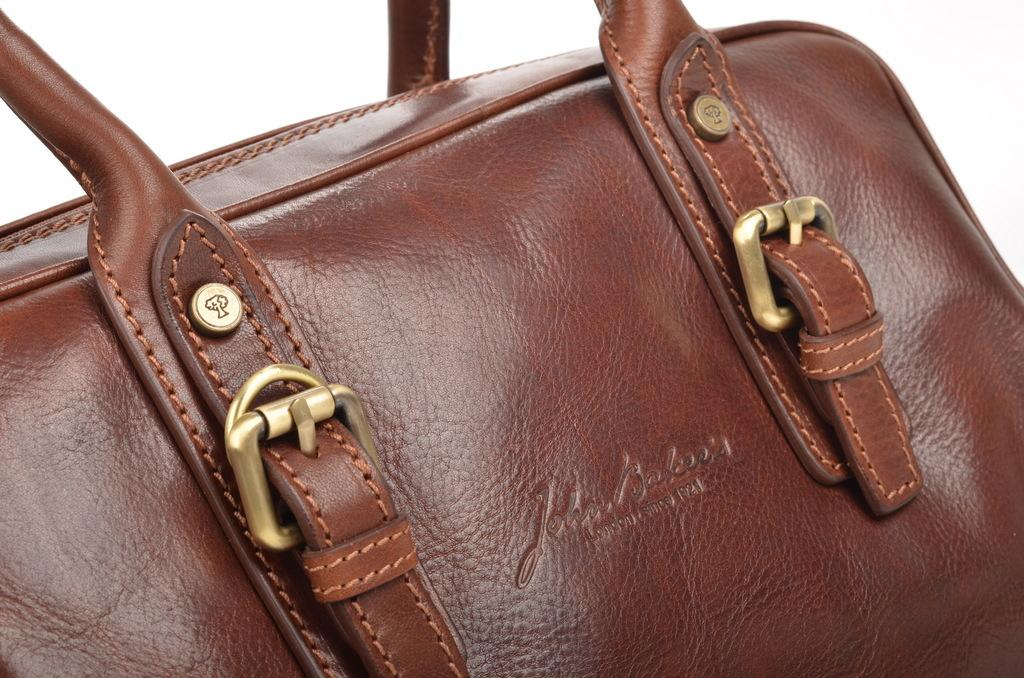What type of handbag is visible in the image? There is a leather handbag in the image. What type of drum can be seen in the image? There is no drum present in the image; it only features a leather handbag. 